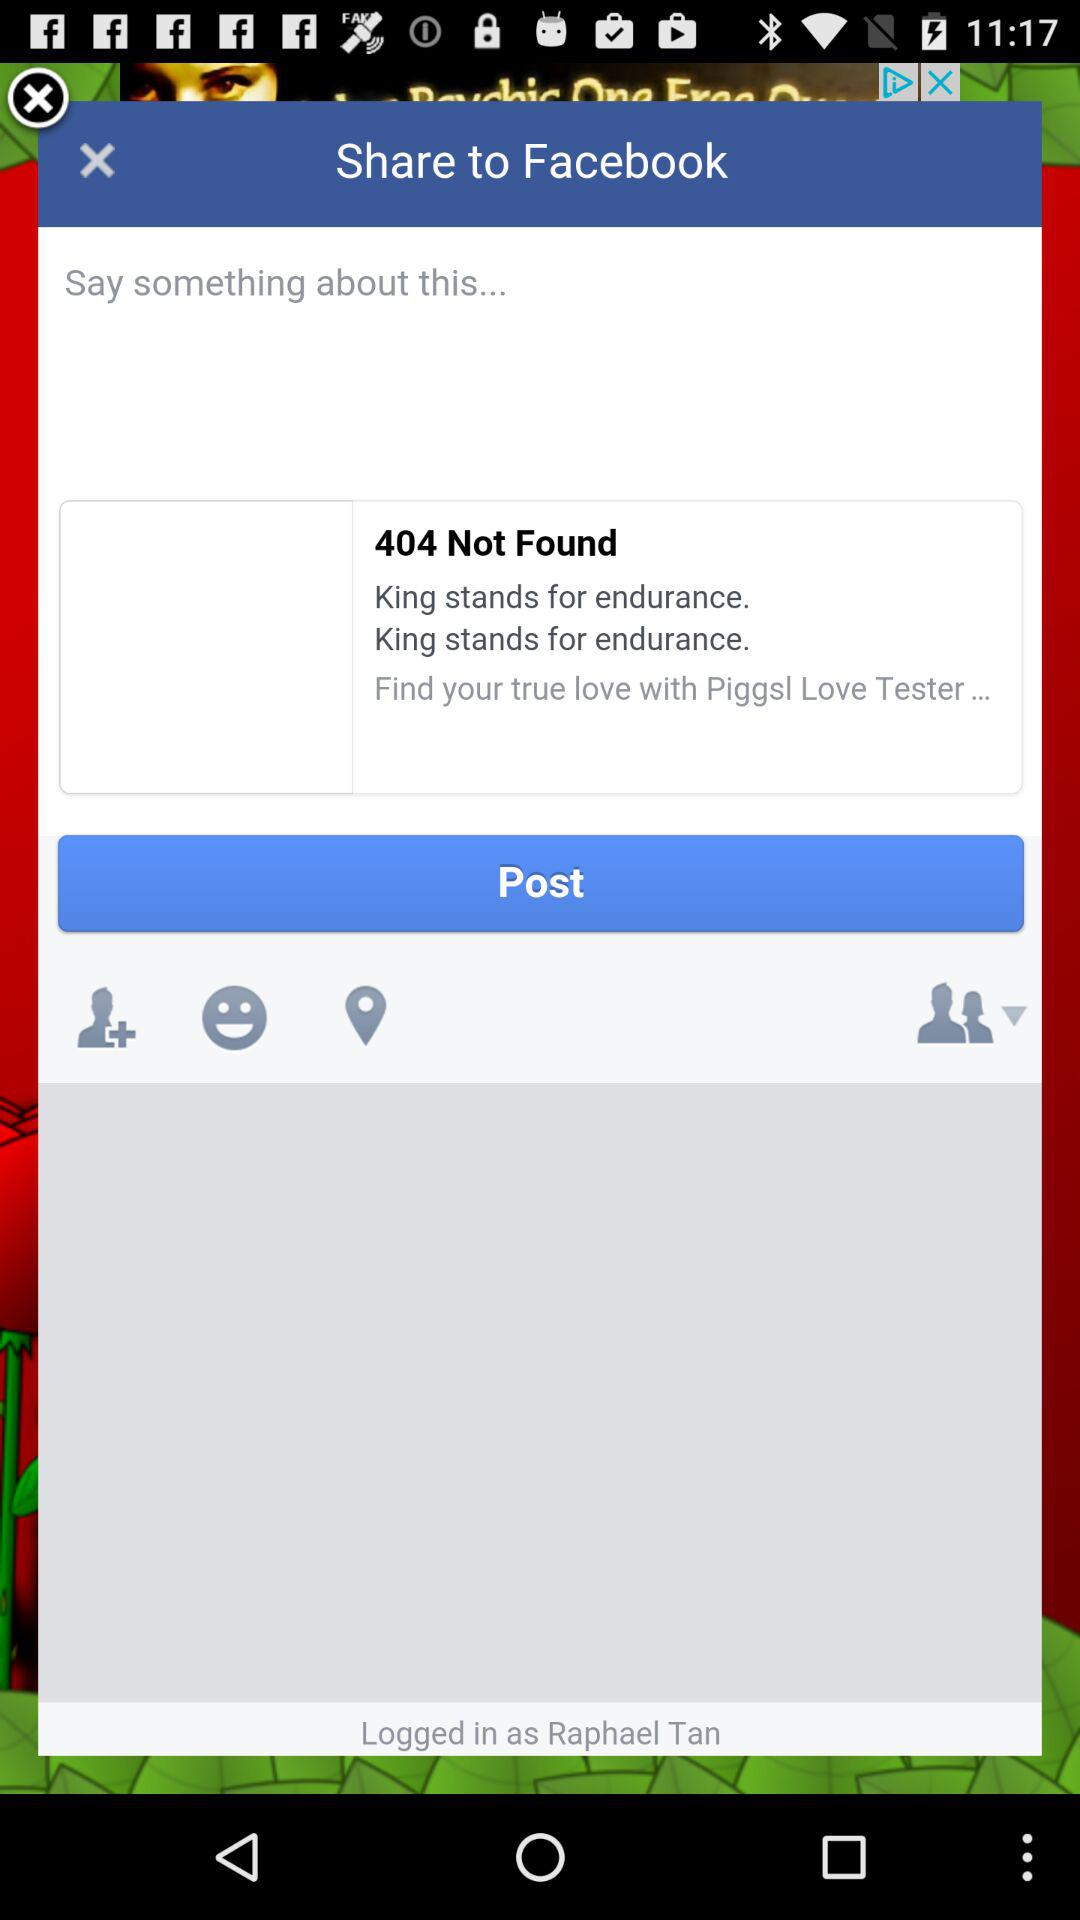What is the name of the user? The name of the user is "Raphael Tan". 